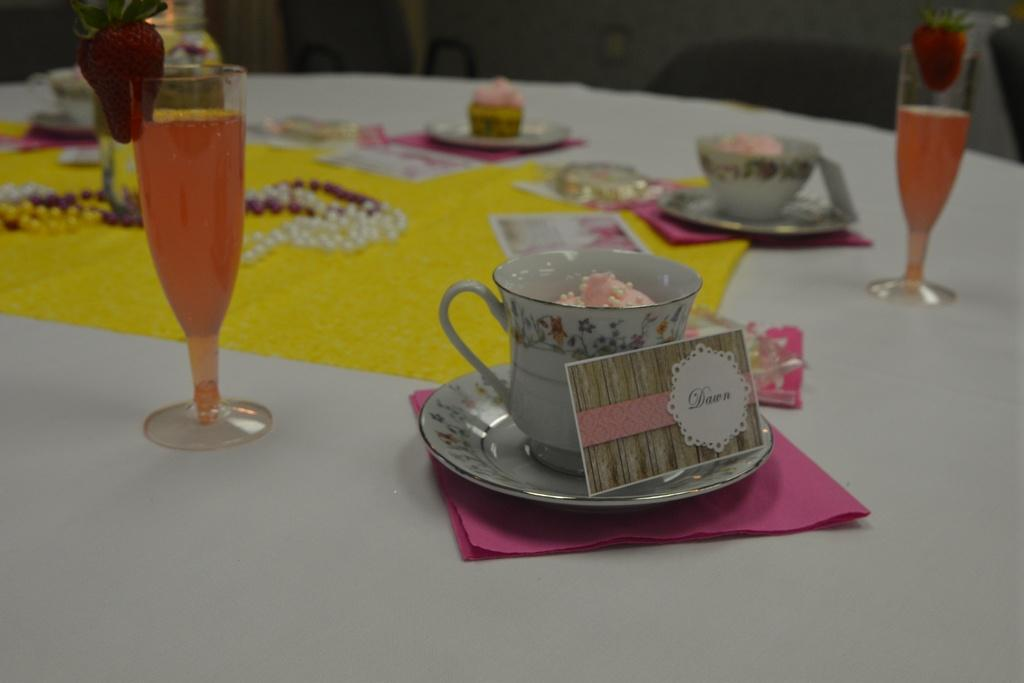What type of glasses are visible in the image? There are juice glasses with strawberries in the image. What other food items can be seen in the image? There are cupcakes in the image. What might be used for cleaning or wiping in the image? Tissue papers are present in the image. What type of jewelry is on the table in the image? There is a pearl chain on the table in the image. How much profit can be made from the juice glasses in the image? There is no information about profit in the image, as it only shows juice glasses with strawberries, cupcakes, tissue papers, and a pearl chain. 